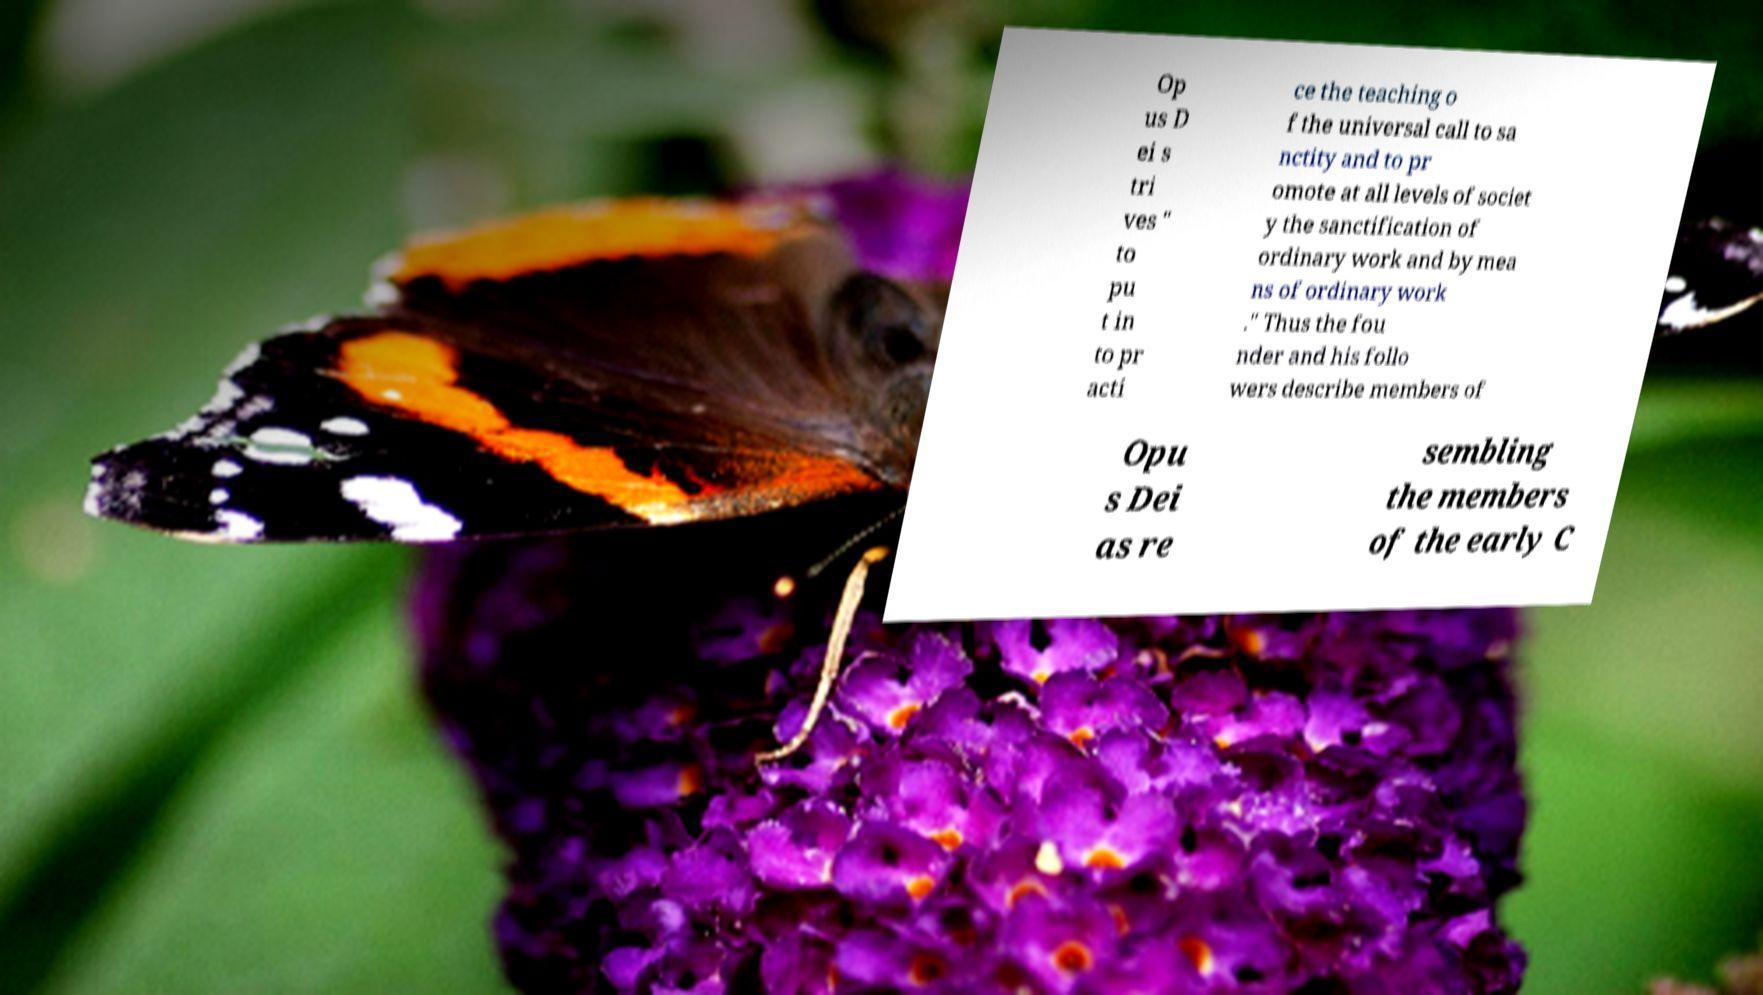Please read and relay the text visible in this image. What does it say? Op us D ei s tri ves " to pu t in to pr acti ce the teaching o f the universal call to sa nctity and to pr omote at all levels of societ y the sanctification of ordinary work and by mea ns of ordinary work ." Thus the fou nder and his follo wers describe members of Opu s Dei as re sembling the members of the early C 